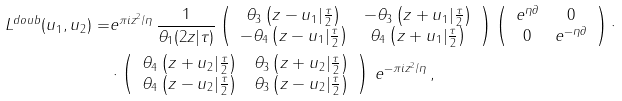<formula> <loc_0><loc_0><loc_500><loc_500>L ^ { d o u b } ( u _ { 1 } , u _ { 2 } ) = & e ^ { \pi i z ^ { 2 } / \eta } \, \frac { 1 } { \theta _ { 1 } ( 2 z | \tau ) } \left ( \begin{array} { c c } \theta _ { 3 } \left ( z - u _ { 1 } | \frac { \tau } { 2 } \right ) & - \theta _ { 3 } \left ( z + u _ { 1 } | \frac { \tau } { 2 } \right ) \\ - \theta _ { 4 } \left ( z - u _ { 1 } | \frac { \tau } { 2 } \right ) & \theta _ { 4 } \left ( z + u _ { 1 } | \frac { \tau } { 2 } \right ) \end{array} \right ) \left ( \begin{array} { c c } e ^ { \eta \partial } & 0 \\ 0 & e ^ { - \eta \partial } \end{array} \right ) \cdot \\ & \cdot \left ( \begin{array} { c c } \theta _ { 4 } \left ( z + u _ { 2 } | \frac { \tau } { 2 } \right ) & \theta _ { 3 } \left ( z + u _ { 2 } | \frac { \tau } { 2 } \right ) \\ \theta _ { 4 } \left ( z - u _ { 2 } | \frac { \tau } { 2 } \right ) & \theta _ { 3 } \left ( z - u _ { 2 } | \frac { \tau } { 2 } \right ) \end{array} \right ) \, e ^ { - \pi i z ^ { 2 } / \eta } \, ,</formula> 